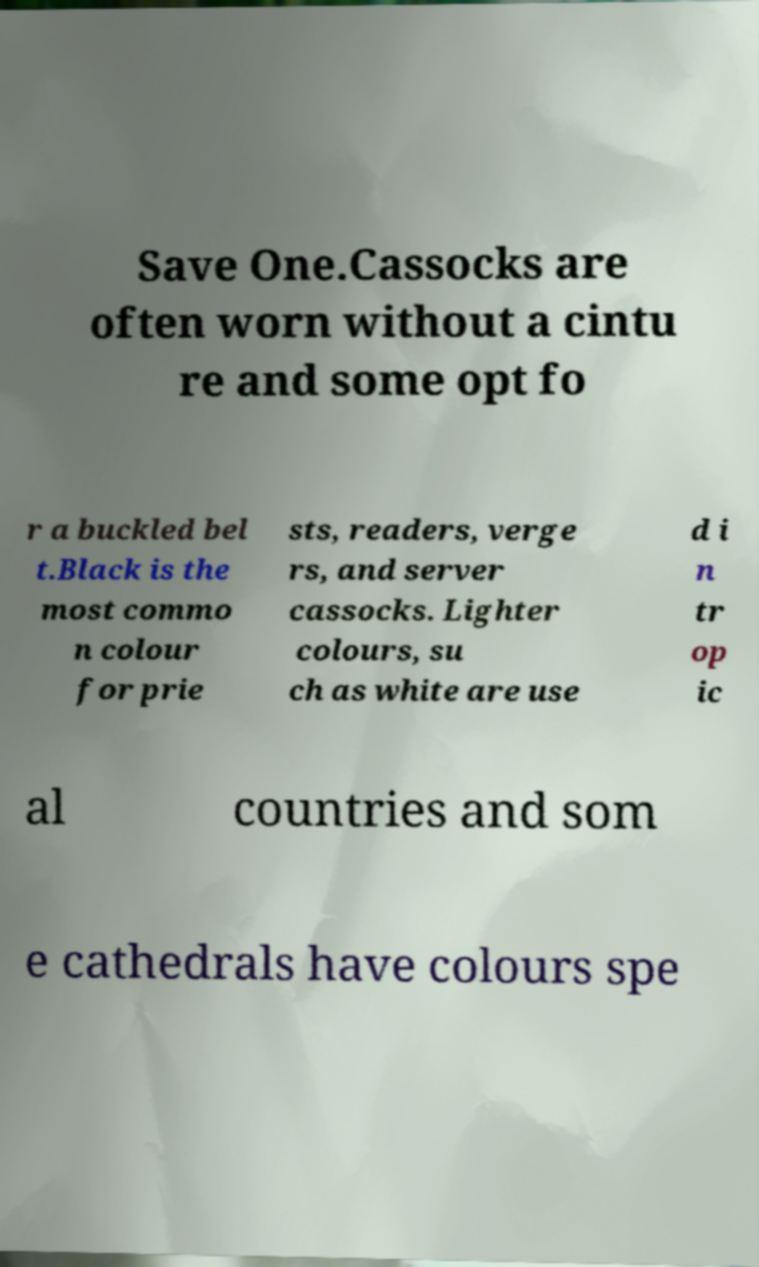Could you assist in decoding the text presented in this image and type it out clearly? Save One.Cassocks are often worn without a cintu re and some opt fo r a buckled bel t.Black is the most commo n colour for prie sts, readers, verge rs, and server cassocks. Lighter colours, su ch as white are use d i n tr op ic al countries and som e cathedrals have colours spe 